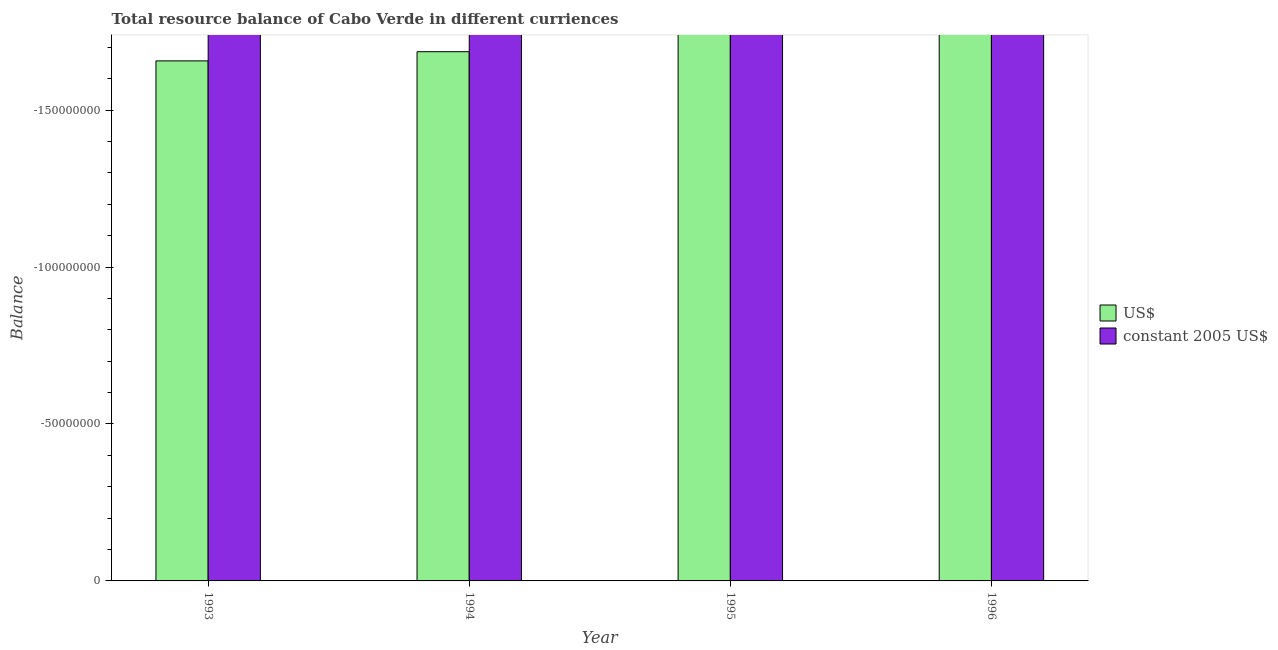How many different coloured bars are there?
Keep it short and to the point. 0. How many bars are there on the 1st tick from the left?
Give a very brief answer. 0. How many bars are there on the 3rd tick from the right?
Offer a terse response. 0. What is the label of the 1st group of bars from the left?
Offer a terse response. 1993. In how many cases, is the number of bars for a given year not equal to the number of legend labels?
Ensure brevity in your answer.  4. What is the resource balance in us$ in 1994?
Offer a very short reply. 0. What is the total resource balance in us$ in the graph?
Your response must be concise. 0. What is the difference between the resource balance in constant us$ in 1996 and the resource balance in us$ in 1993?
Offer a very short reply. 0. In how many years, is the resource balance in constant us$ greater than the average resource balance in constant us$ taken over all years?
Keep it short and to the point. 0. Are all the bars in the graph horizontal?
Offer a terse response. No. Does the graph contain any zero values?
Provide a succinct answer. Yes. Where does the legend appear in the graph?
Keep it short and to the point. Center right. What is the title of the graph?
Keep it short and to the point. Total resource balance of Cabo Verde in different curriences. Does "Highest 20% of population" appear as one of the legend labels in the graph?
Provide a short and direct response. No. What is the label or title of the X-axis?
Your answer should be very brief. Year. What is the label or title of the Y-axis?
Your answer should be very brief. Balance. What is the Balance of constant 2005 US$ in 1993?
Give a very brief answer. 0. What is the Balance of constant 2005 US$ in 1995?
Offer a terse response. 0. What is the Balance of constant 2005 US$ in 1996?
Offer a very short reply. 0. What is the average Balance in US$ per year?
Offer a very short reply. 0. What is the average Balance in constant 2005 US$ per year?
Provide a short and direct response. 0. 